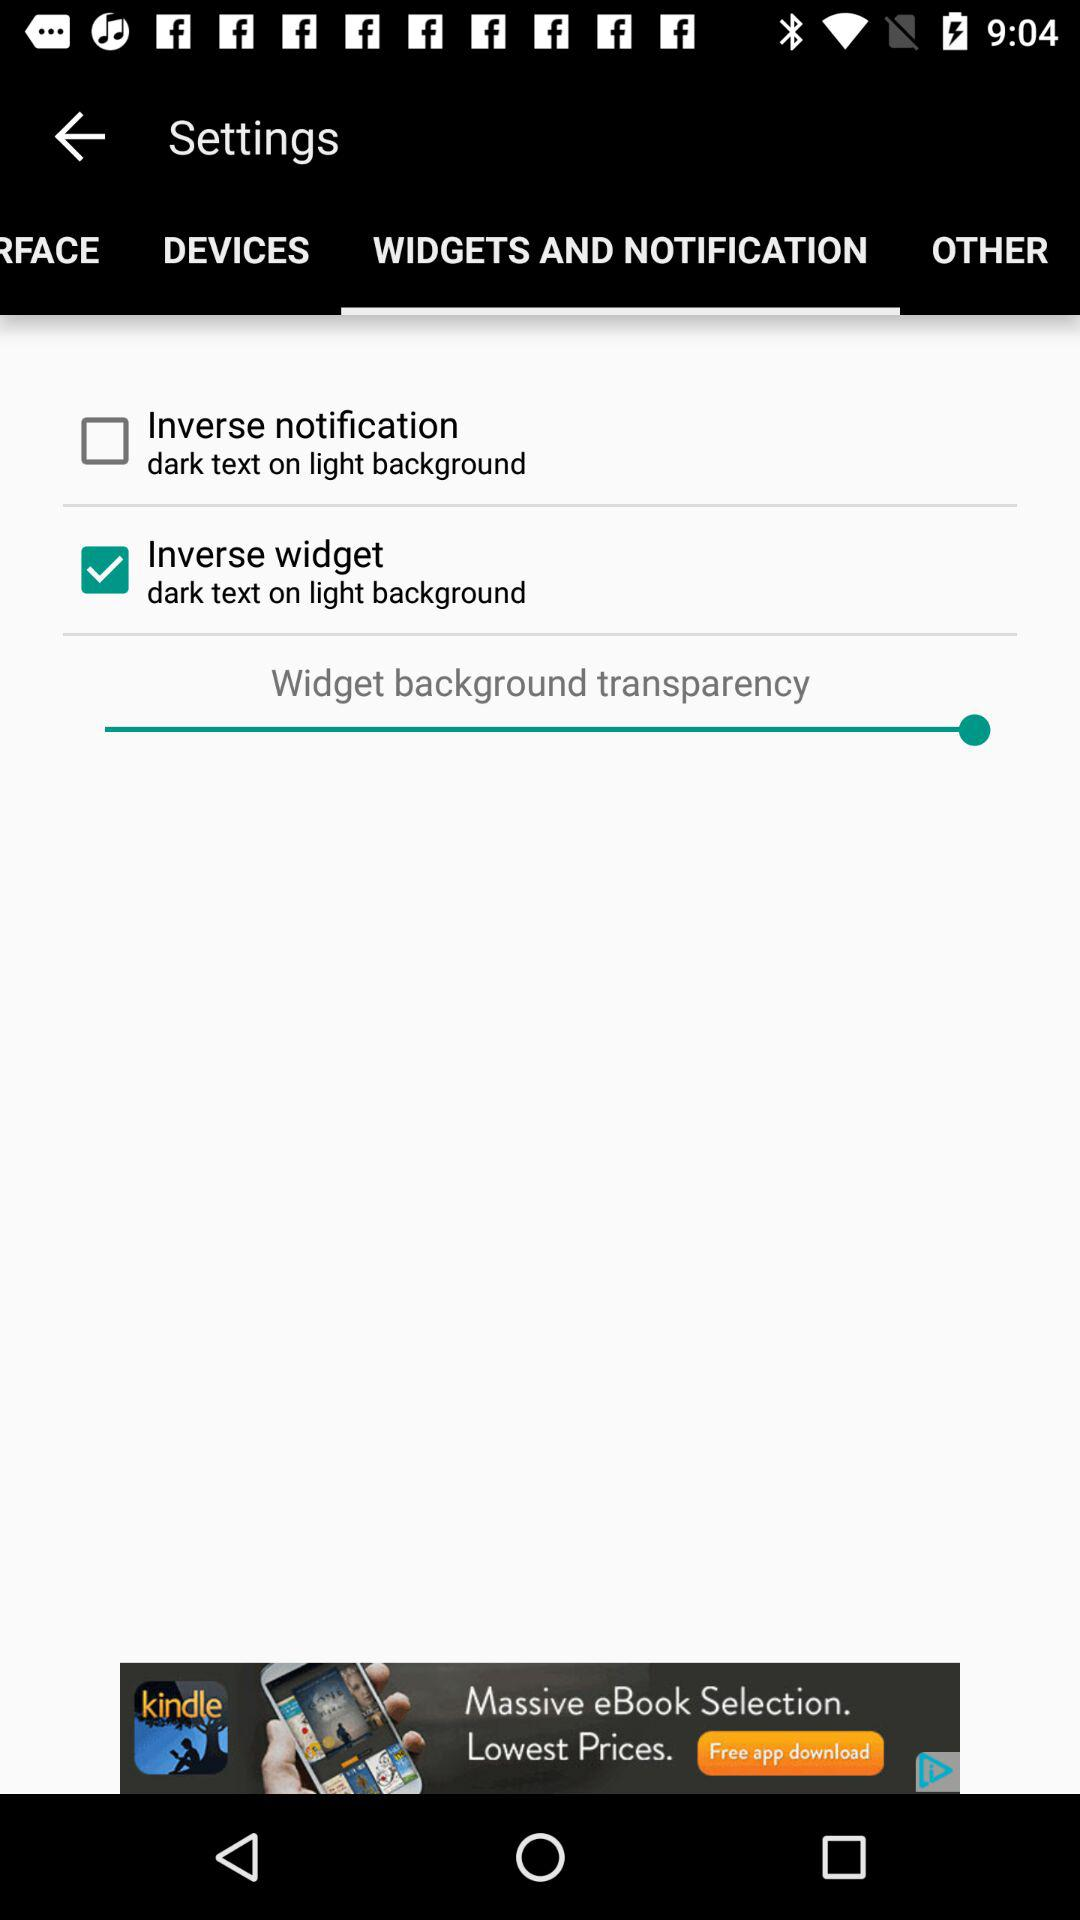Which tab has been selected? The tab "WIDGETS AND NOTIFICATION" has been selected. 